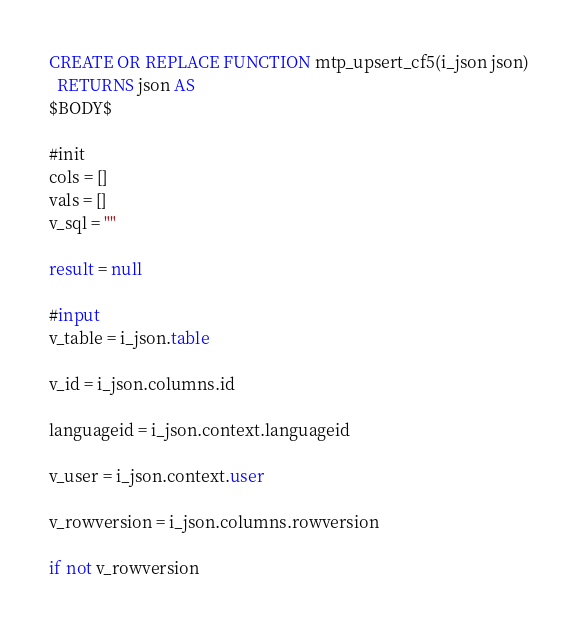<code> <loc_0><loc_0><loc_500><loc_500><_SQL_>CREATE OR REPLACE FUNCTION mtp_upsert_cf5(i_json json)
  RETURNS json AS
$BODY$

#init
cols = []
vals = []
v_sql = ""

result = null

#input
v_table = i_json.table

v_id = i_json.columns.id

languageid = i_json.context.languageid

v_user = i_json.context.user

v_rowversion = i_json.columns.rowversion

if not v_rowversion</code> 